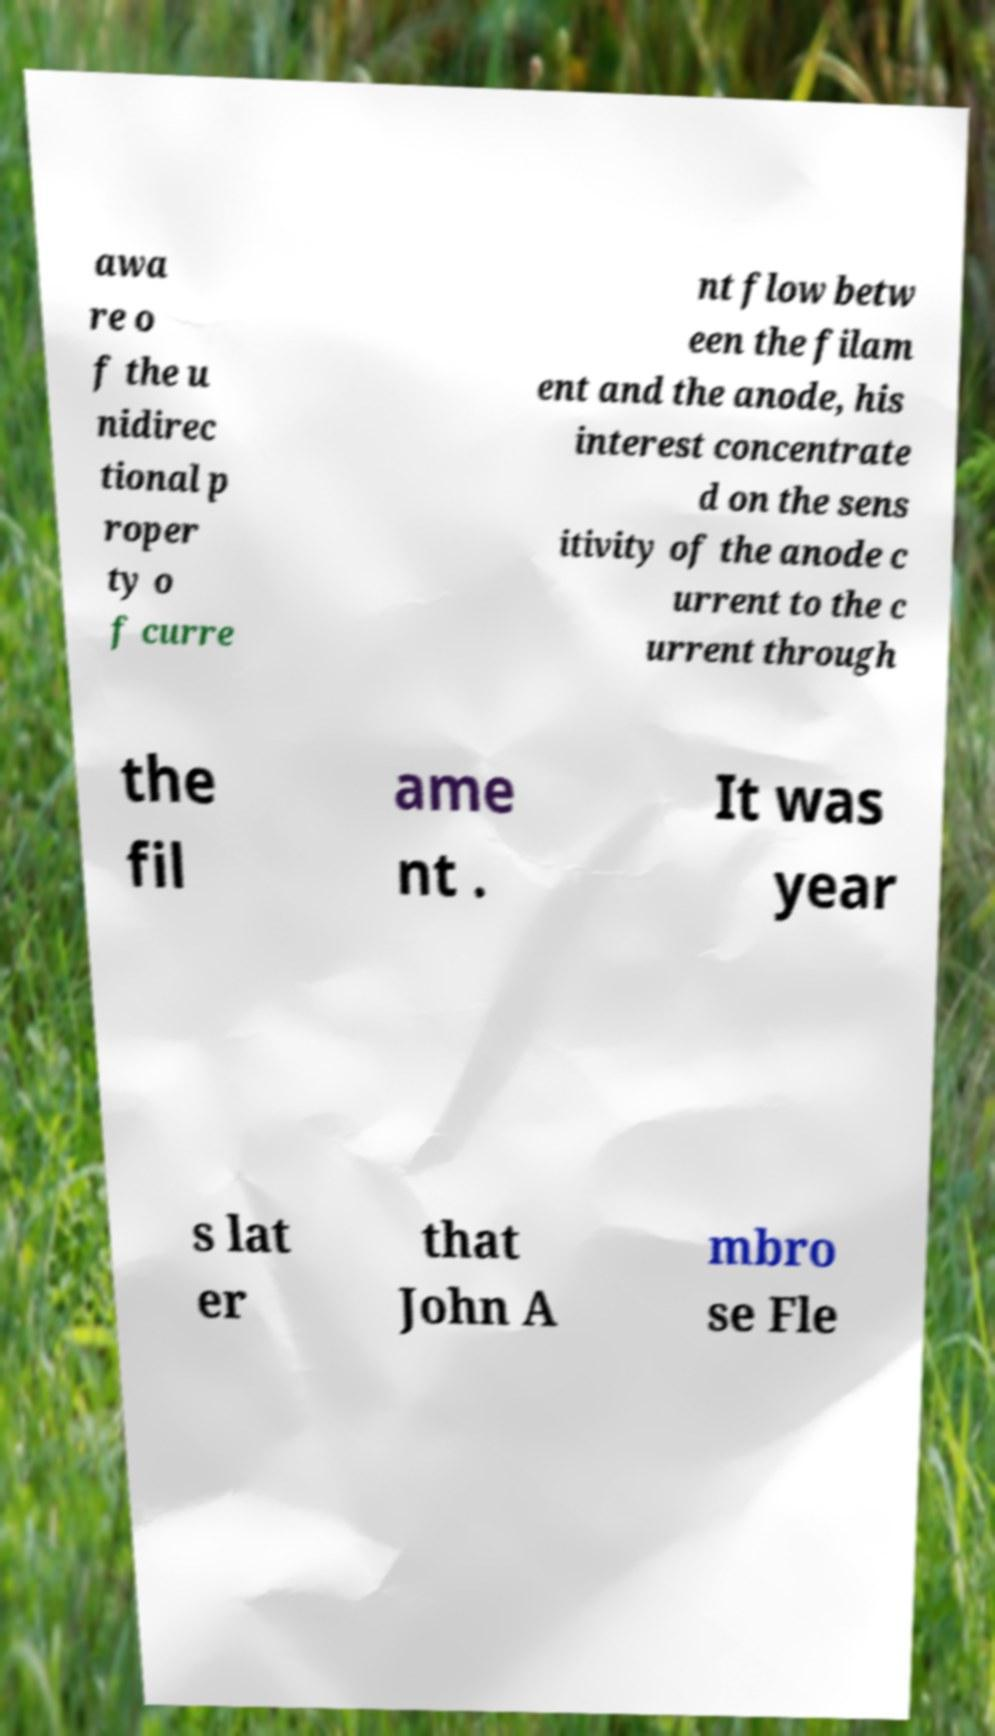Can you read and provide the text displayed in the image?This photo seems to have some interesting text. Can you extract and type it out for me? awa re o f the u nidirec tional p roper ty o f curre nt flow betw een the filam ent and the anode, his interest concentrate d on the sens itivity of the anode c urrent to the c urrent through the fil ame nt . It was year s lat er that John A mbro se Fle 